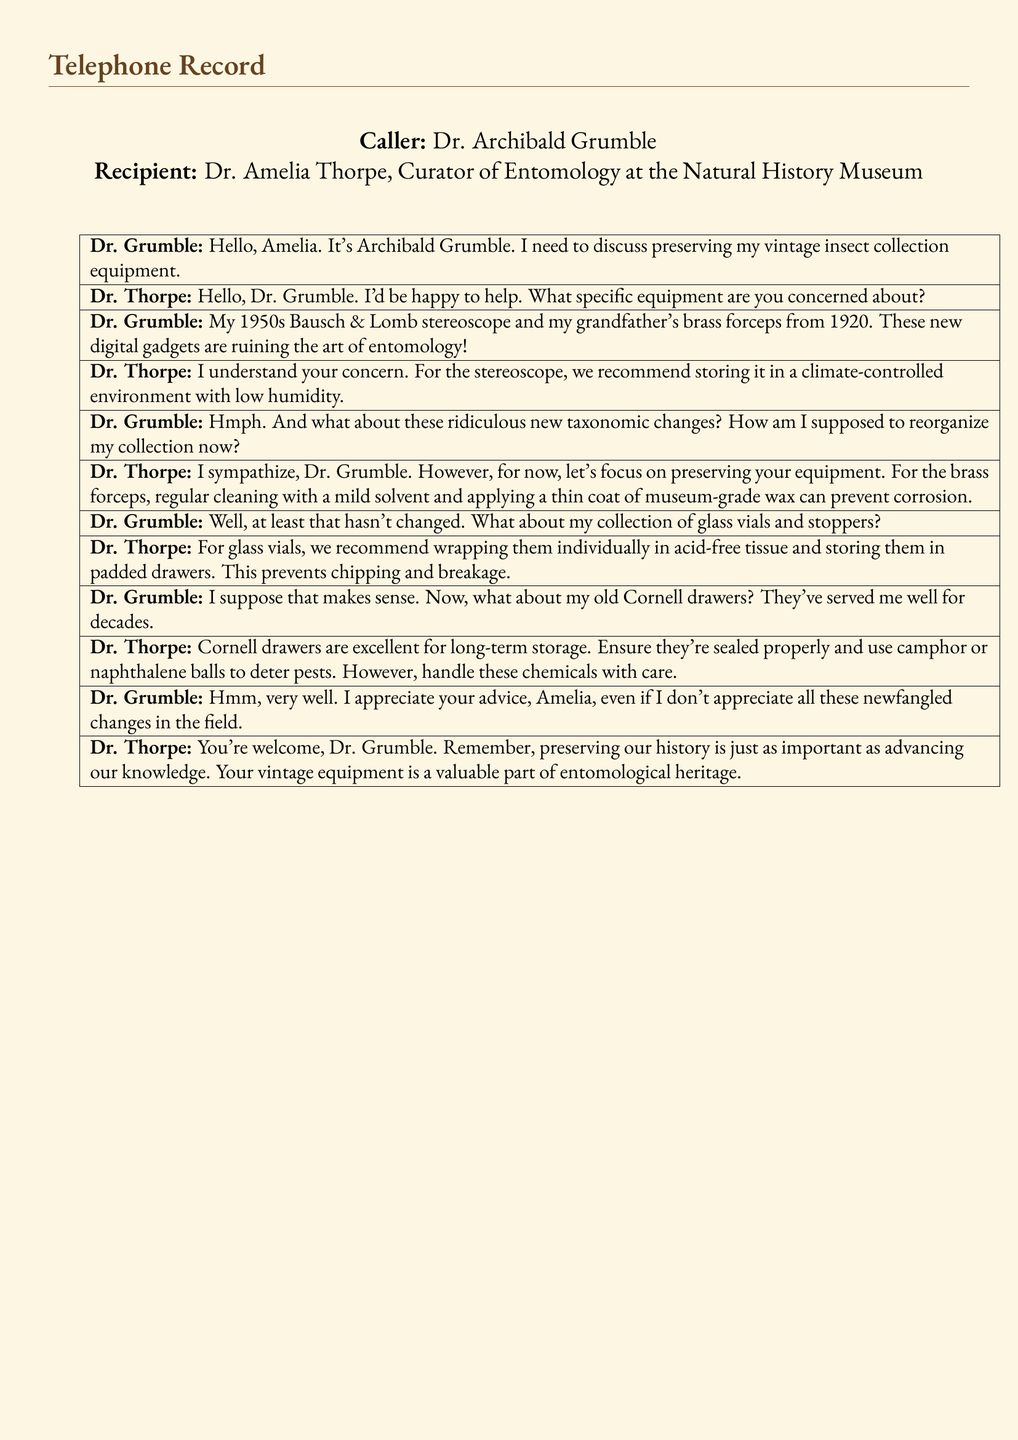What is the name of the curator? The curator's name is mentioned in the document as Dr. Amelia Thorpe, who works at the Natural History Museum.
Answer: Dr. Amelia Thorpe What year is the Bausch & Lomb stereoscope from? The conversation specifies that the Bausch & Lomb stereoscope is from the 1950s.
Answer: 1950s What is the recommended storage for the stereoscope? Dr. Thorpe suggests storing the stereoscope in a climate-controlled environment with low humidity.
Answer: Climate-controlled environment with low humidity What should be used to clean the brass forceps? The conversation advises using a mild solvent for cleaning the brass forceps.
Answer: Mild solvent How should glass vials be stored? Dr. Thorpe recommends wrapping glass vials individually in acid-free tissue and storing them in padded drawers.
Answer: Wrapped in acid-free tissue What type of drawers are mentioned as being good for long-term storage? The document mentions Cornell drawers as excellent for long-term storage of collections.
Answer: Cornell drawers What can be used to deter pests in drawers? The document advises using camphor or naphthalene balls to deter pests in the drawers.
Answer: Camphor or naphthalene balls Who is the caller in the telephone record? The document states that the caller is Dr. Archibald Grumble.
Answer: Dr. Archibald Grumble What does Dr. Thorpe say about preserving history? Dr. Thorpe mentions that preserving history is just as important as advancing knowledge.
Answer: Preserving history is just as important as advancing knowledge 